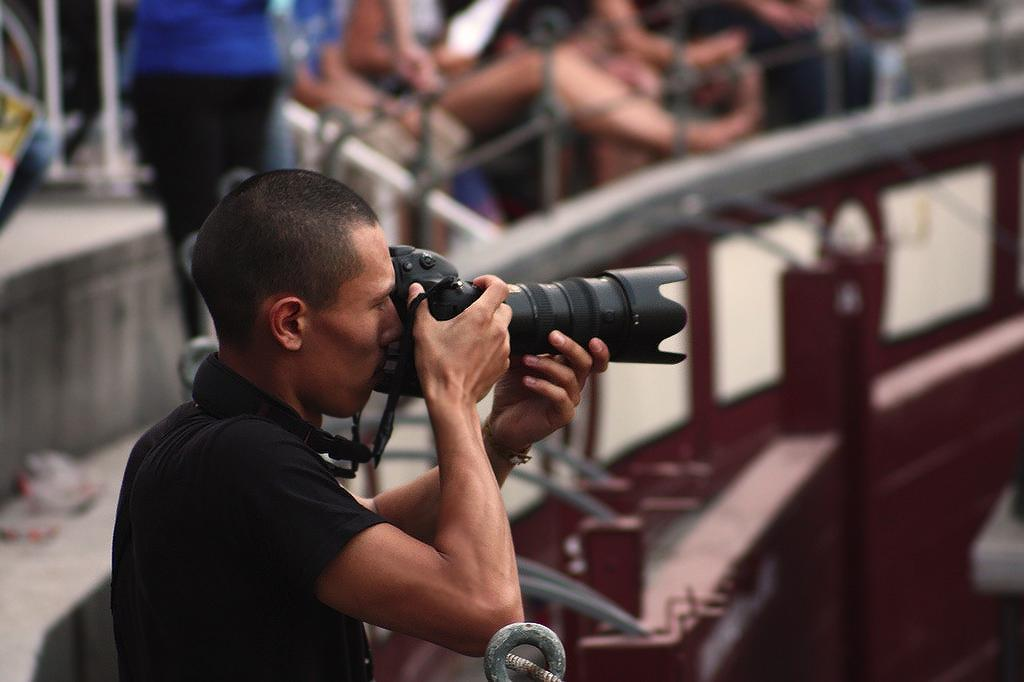How many people are in the image? There are people in the image. Can you describe the position of the man in the image? A man is standing in the front. What is the man wearing in the image? The man is wearing a black t-shirt. What is the man holding in the image? The man is holding a camera. In which direction is the man moving in the image? The man is not moving in the image; he is standing still. How does the man lift the camera in the image? The image does not show the man lifting the camera, only holding it. 